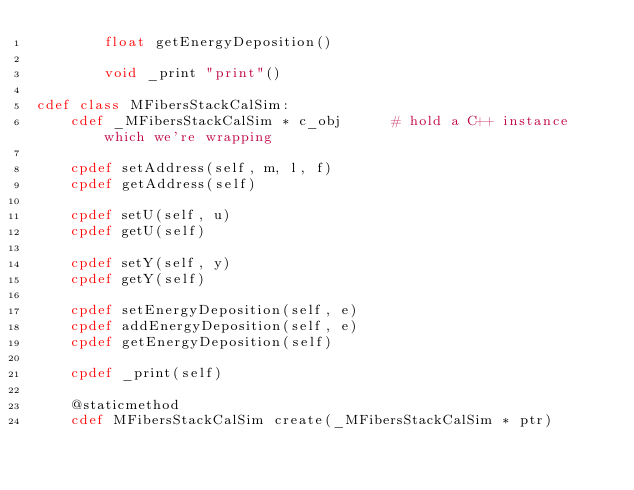Convert code to text. <code><loc_0><loc_0><loc_500><loc_500><_Cython_>        float getEnergyDeposition()
        
        void _print "print"()

cdef class MFibersStackCalSim:
    cdef _MFibersStackCalSim * c_obj      # hold a C++ instance which we're wrapping

    cpdef setAddress(self, m, l, f)
    cpdef getAddress(self)

    cpdef setU(self, u)
    cpdef getU(self)

    cpdef setY(self, y)
    cpdef getY(self)

    cpdef setEnergyDeposition(self, e)
    cpdef addEnergyDeposition(self, e)
    cpdef getEnergyDeposition(self)

    cpdef _print(self)

    @staticmethod
    cdef MFibersStackCalSim create(_MFibersStackCalSim * ptr)
</code> 